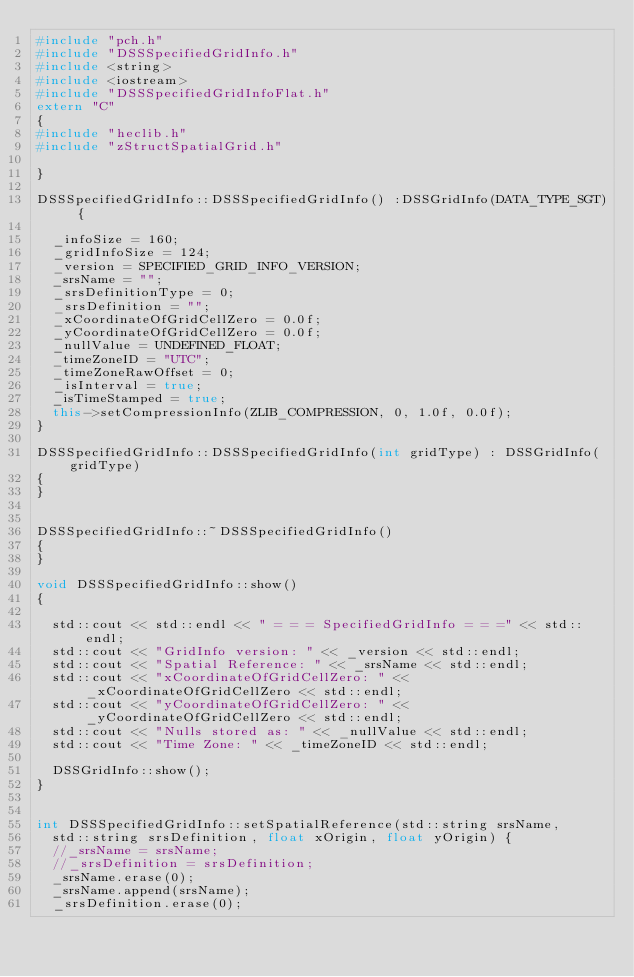<code> <loc_0><loc_0><loc_500><loc_500><_C++_>#include "pch.h"
#include "DSSSpecifiedGridInfo.h"
#include <string>
#include <iostream>
#include "DSSSpecifiedGridInfoFlat.h"
extern "C"
{
#include "heclib.h"
#include "zStructSpatialGrid.h"

}

DSSSpecifiedGridInfo::DSSSpecifiedGridInfo() :DSSGridInfo(DATA_TYPE_SGT) {

  _infoSize = 160;
  _gridInfoSize = 124;
  _version = SPECIFIED_GRID_INFO_VERSION;
  _srsName = "";
  _srsDefinitionType = 0;
  _srsDefinition = "";
  _xCoordinateOfGridCellZero = 0.0f;
  _yCoordinateOfGridCellZero = 0.0f;
  _nullValue = UNDEFINED_FLOAT;
  _timeZoneID = "UTC";
  _timeZoneRawOffset = 0;
  _isInterval = true;
  _isTimeStamped = true;
  this->setCompressionInfo(ZLIB_COMPRESSION, 0, 1.0f, 0.0f);
}

DSSSpecifiedGridInfo::DSSSpecifiedGridInfo(int gridType) : DSSGridInfo(gridType)
{
}


DSSSpecifiedGridInfo::~DSSSpecifiedGridInfo()
{
}

void DSSSpecifiedGridInfo::show()
{

  std::cout << std::endl << " = = = SpecifiedGridInfo = = =" << std::endl;
  std::cout << "GridInfo version: " << _version << std::endl;
  std::cout << "Spatial Reference: " << _srsName << std::endl;
  std::cout << "xCoordinateOfGridCellZero: " << _xCoordinateOfGridCellZero << std::endl;
  std::cout << "yCoordinateOfGridCellZero: " << _yCoordinateOfGridCellZero << std::endl;
  std::cout << "Nulls stored as: " << _nullValue << std::endl;
  std::cout << "Time Zone: " << _timeZoneID << std::endl;

  DSSGridInfo::show();
}


int DSSSpecifiedGridInfo::setSpatialReference(std::string srsName,
  std::string srsDefinition, float xOrigin, float yOrigin) {
  //_srsName = srsName;
  //_srsDefinition = srsDefinition;
  _srsName.erase(0);
  _srsName.append(srsName);
  _srsDefinition.erase(0);</code> 